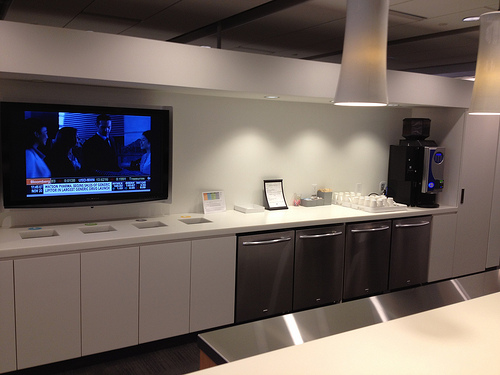Please provide the bounding box coordinate of the region this sentence describes: the lights hanging from the ceiling. The bounding box coordinates for the lights hanging from the ceiling are [0.66, 0.12, 1.0, 0.37]. 